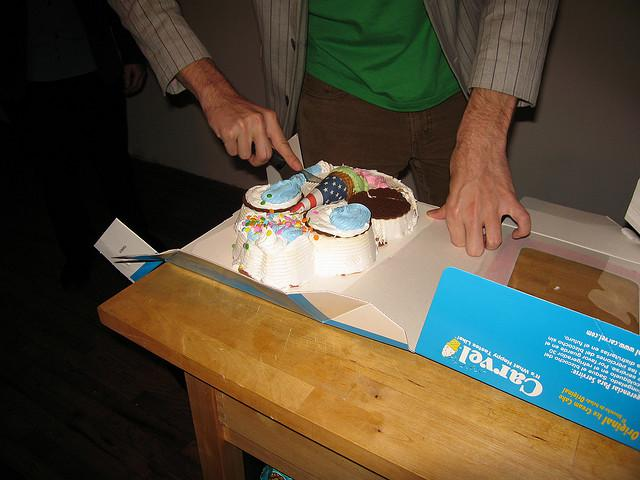What cool treat can be found inside this cake? Please explain your reasoning. ice cream. The cake was bought at carvel, which is an ice cream shop that sells ice cream cakes. 